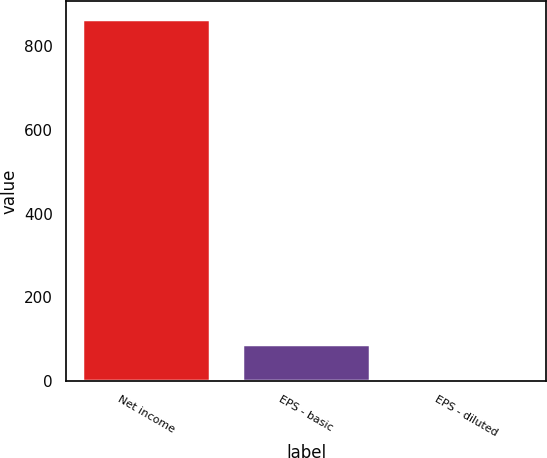<chart> <loc_0><loc_0><loc_500><loc_500><bar_chart><fcel>Net income<fcel>EPS - basic<fcel>EPS - diluted<nl><fcel>865<fcel>88.52<fcel>2.24<nl></chart> 